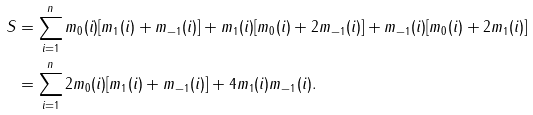Convert formula to latex. <formula><loc_0><loc_0><loc_500><loc_500>S & = \sum _ { i = 1 } ^ { n } m _ { 0 } ( i ) [ m _ { 1 } ( i ) + m _ { - 1 } ( i ) ] + m _ { 1 } ( i ) [ m _ { 0 } ( i ) + 2 m _ { - 1 } ( i ) ] + m _ { - 1 } ( i ) [ m _ { 0 } ( i ) + 2 m _ { 1 } ( i ) ] \\ & = \sum _ { i = 1 } ^ { n } 2 m _ { 0 } ( i ) [ m _ { 1 } ( i ) + m _ { - 1 } ( i ) ] + 4 m _ { 1 } ( i ) m _ { - 1 } ( i ) .</formula> 